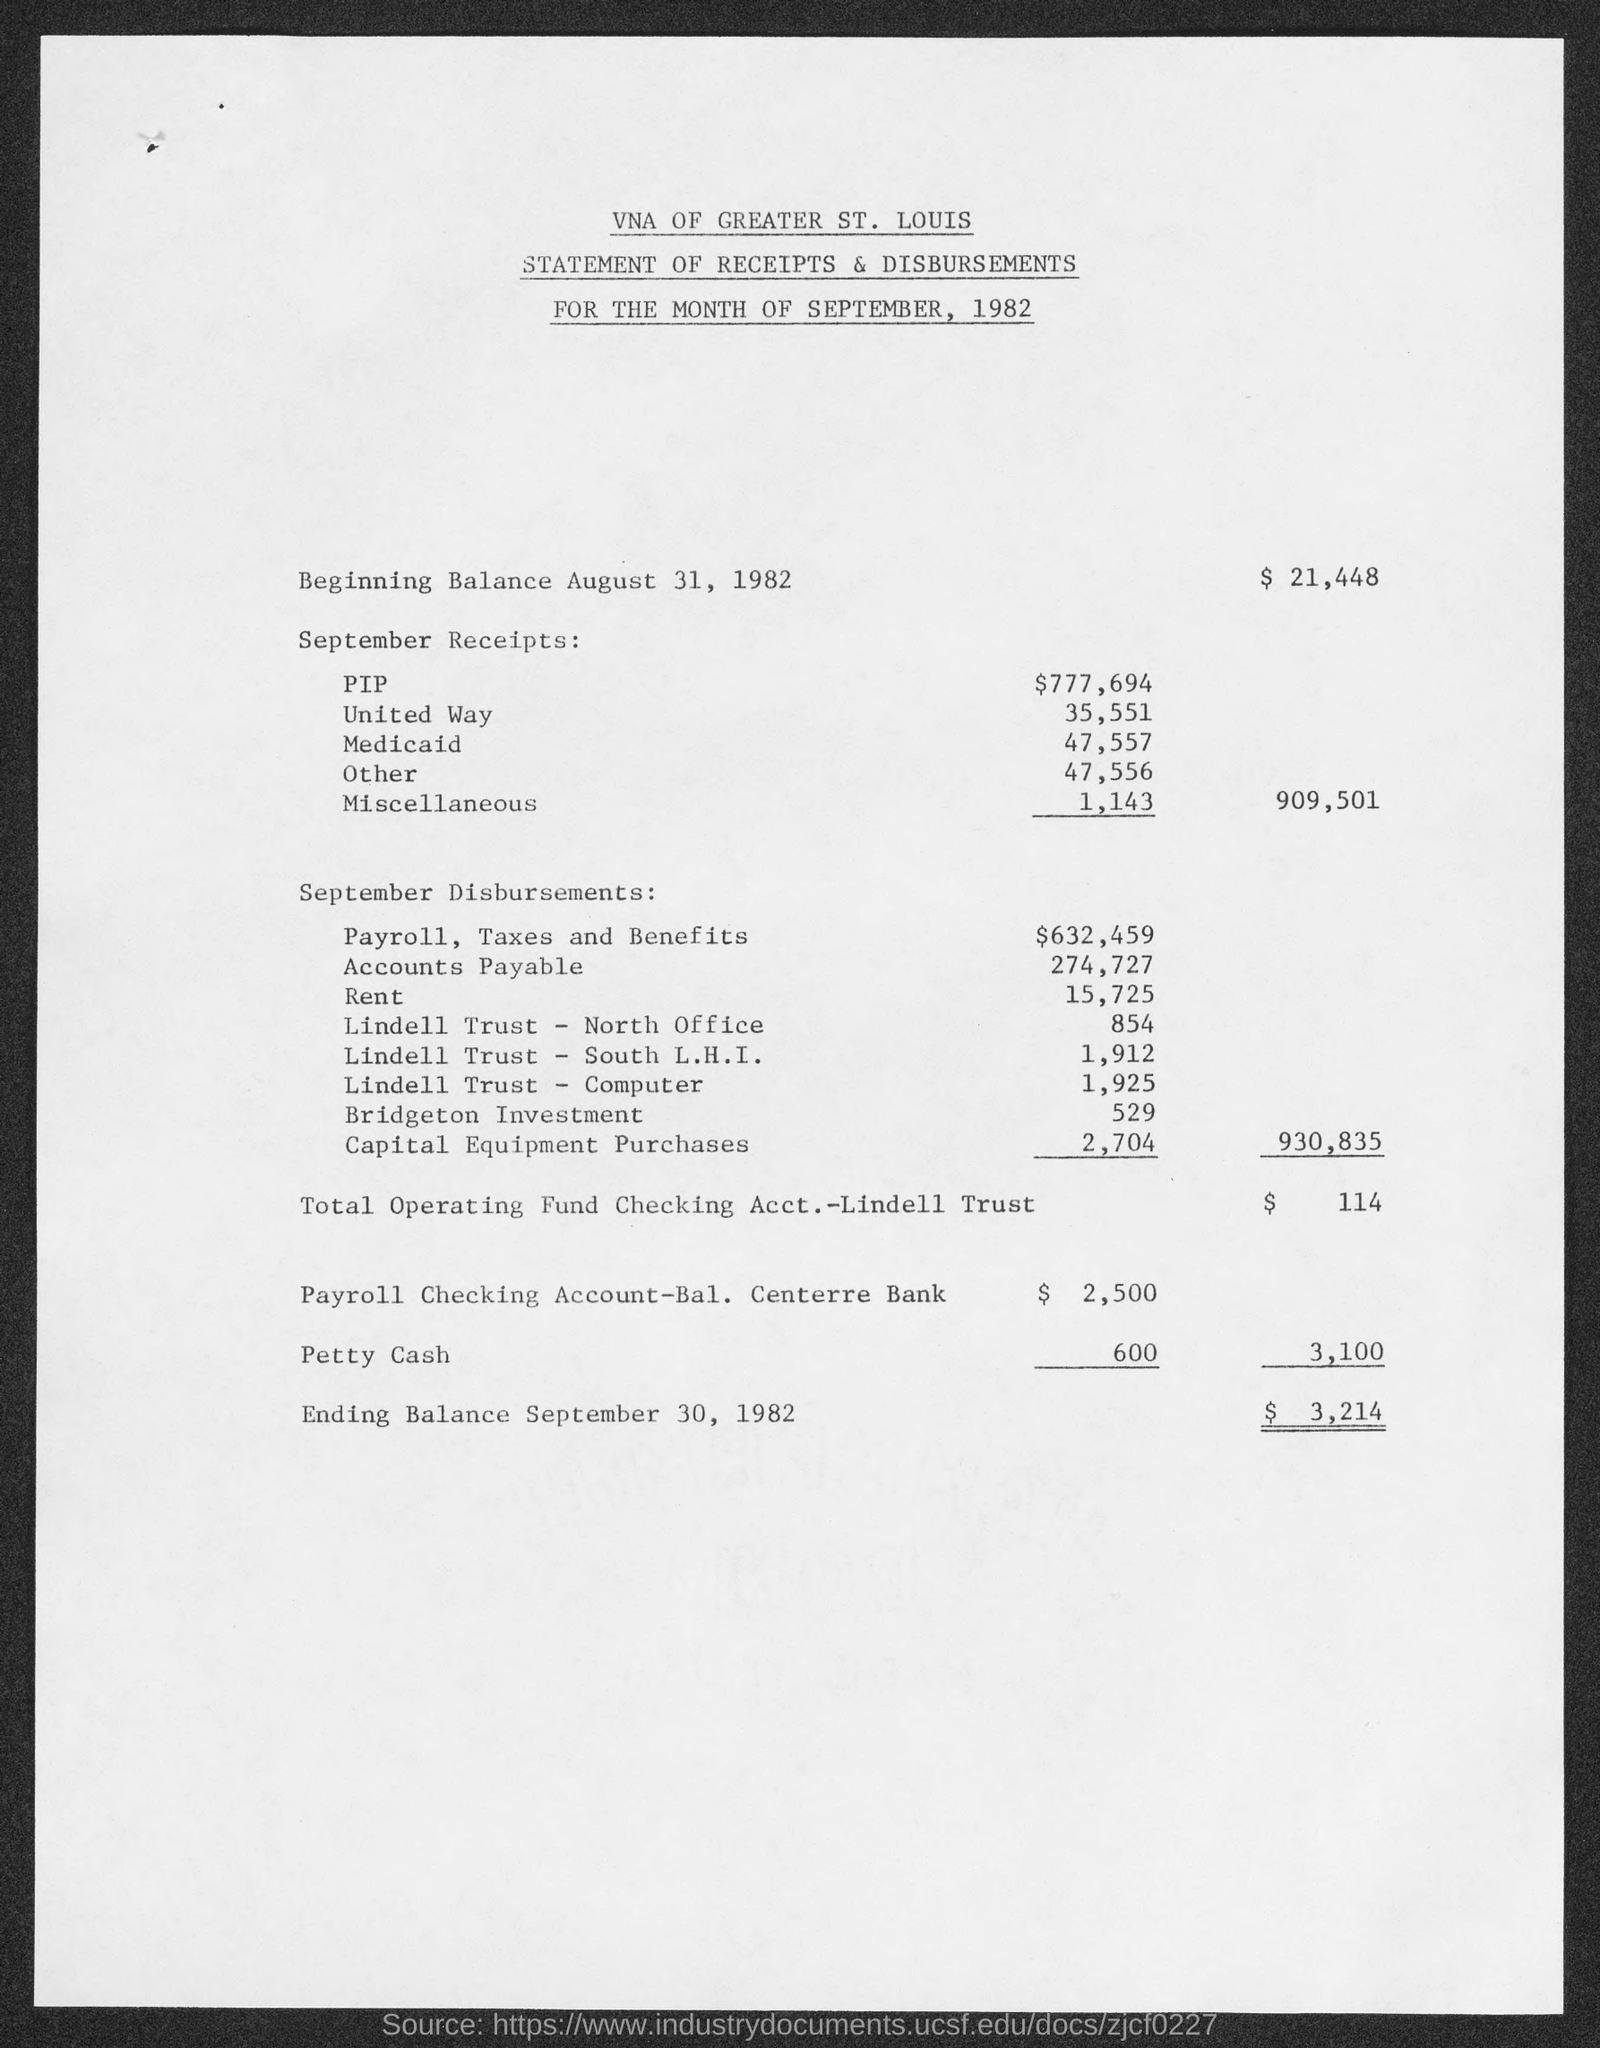Mention a couple of crucial points in this snapshot. The balance in the beginning was $21,448. The first title in the document is "VNA of Greater St. Louis. The rent is 15,725. The balance in the end is $3,214. 